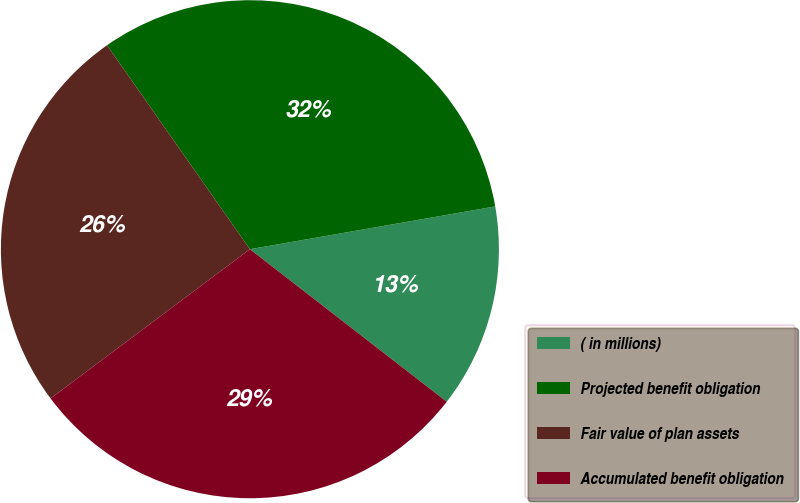Convert chart to OTSL. <chart><loc_0><loc_0><loc_500><loc_500><pie_chart><fcel>( in millions)<fcel>Projected benefit obligation<fcel>Fair value of plan assets<fcel>Accumulated benefit obligation<nl><fcel>13.24%<fcel>31.98%<fcel>25.5%<fcel>29.28%<nl></chart> 